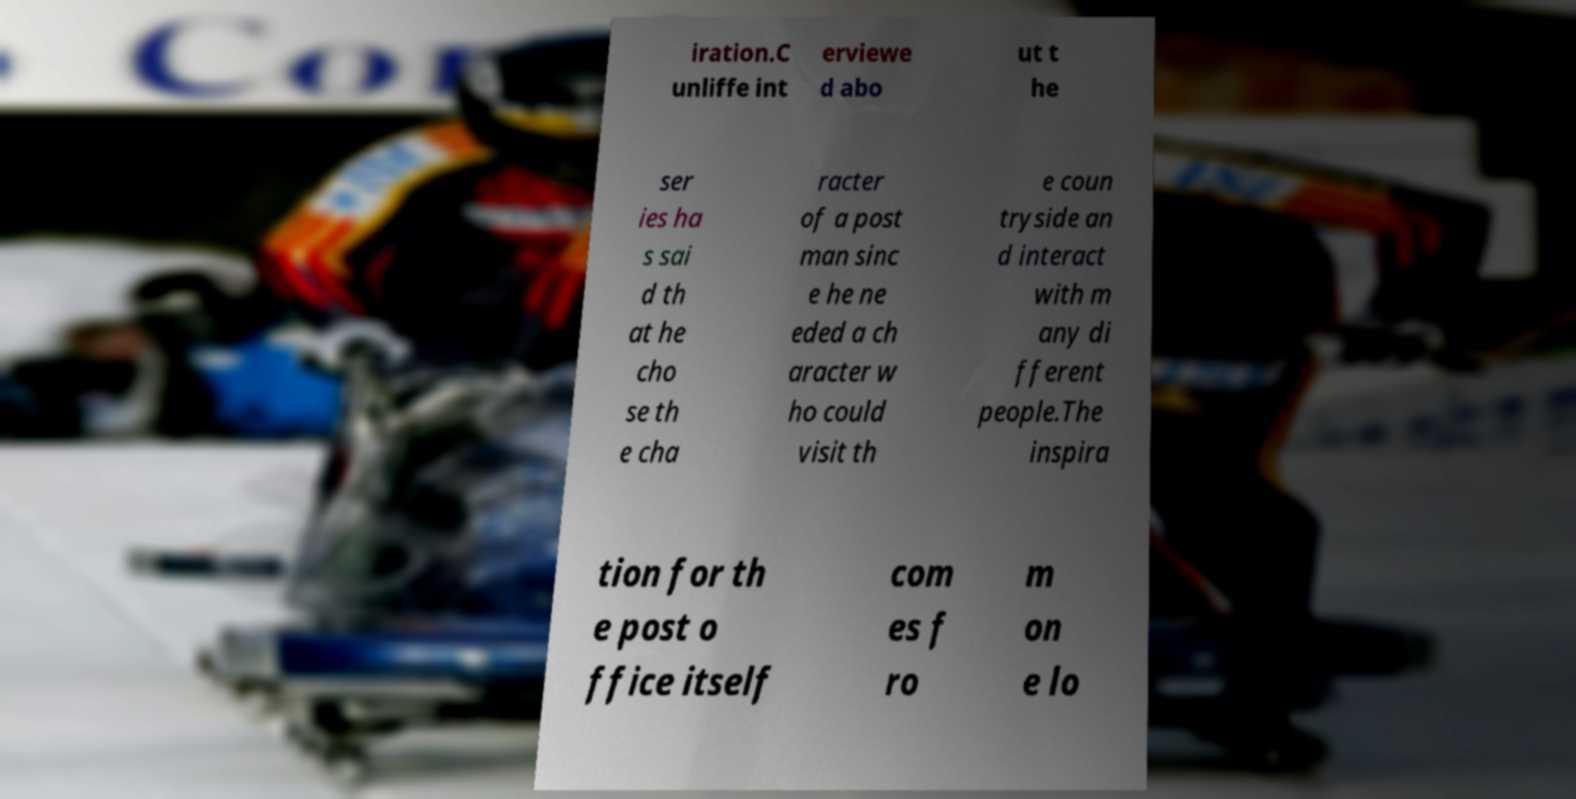Could you assist in decoding the text presented in this image and type it out clearly? iration.C unliffe int erviewe d abo ut t he ser ies ha s sai d th at he cho se th e cha racter of a post man sinc e he ne eded a ch aracter w ho could visit th e coun tryside an d interact with m any di fferent people.The inspira tion for th e post o ffice itself com es f ro m on e lo 